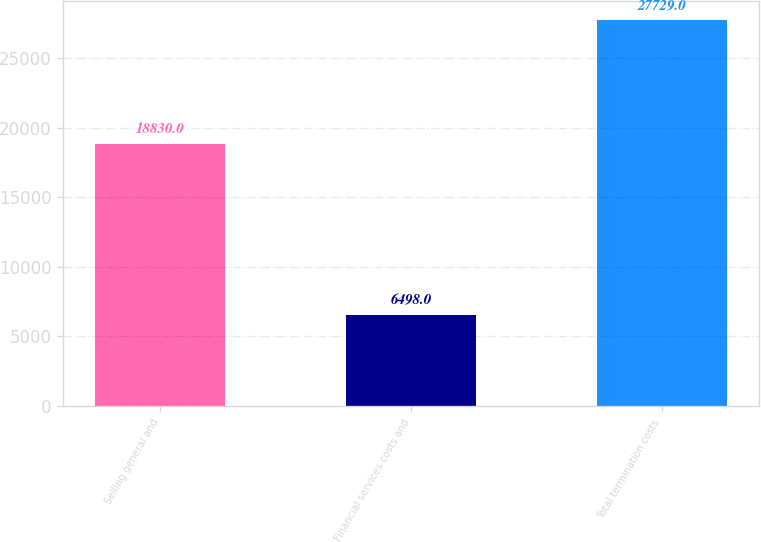Convert chart. <chart><loc_0><loc_0><loc_500><loc_500><bar_chart><fcel>Selling general and<fcel>Financial services costs and<fcel>Total termination costs<nl><fcel>18830<fcel>6498<fcel>27729<nl></chart> 